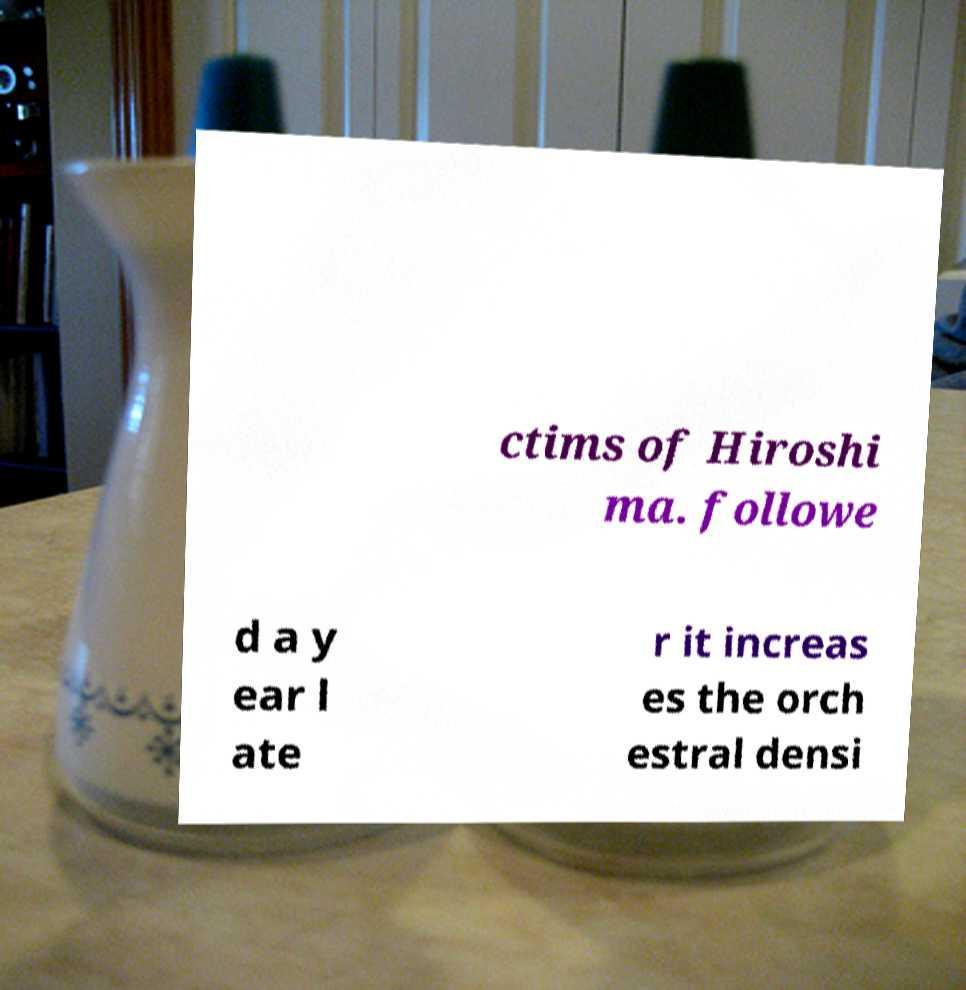What messages or text are displayed in this image? I need them in a readable, typed format. ctims of Hiroshi ma. followe d a y ear l ate r it increas es the orch estral densi 